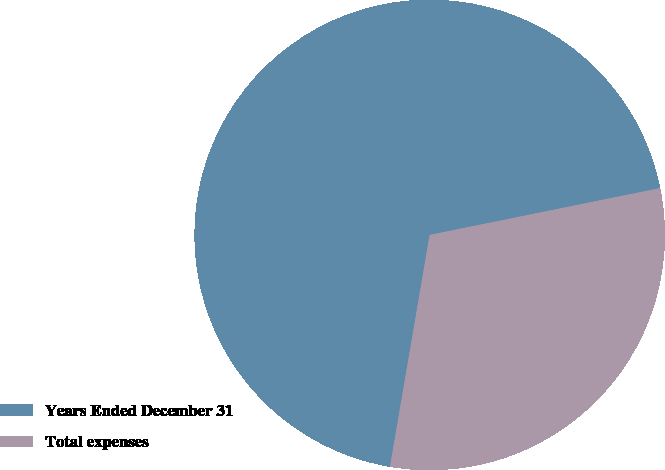Convert chart. <chart><loc_0><loc_0><loc_500><loc_500><pie_chart><fcel>Years Ended December 31<fcel>Total expenses<nl><fcel>69.11%<fcel>30.89%<nl></chart> 